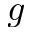Convert formula to latex. <formula><loc_0><loc_0><loc_500><loc_500>g</formula> 